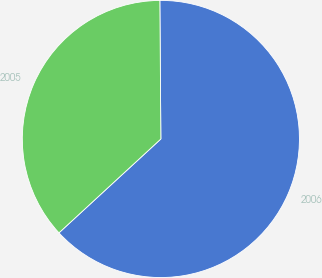Convert chart to OTSL. <chart><loc_0><loc_0><loc_500><loc_500><pie_chart><fcel>2006<fcel>2005<nl><fcel>63.27%<fcel>36.73%<nl></chart> 